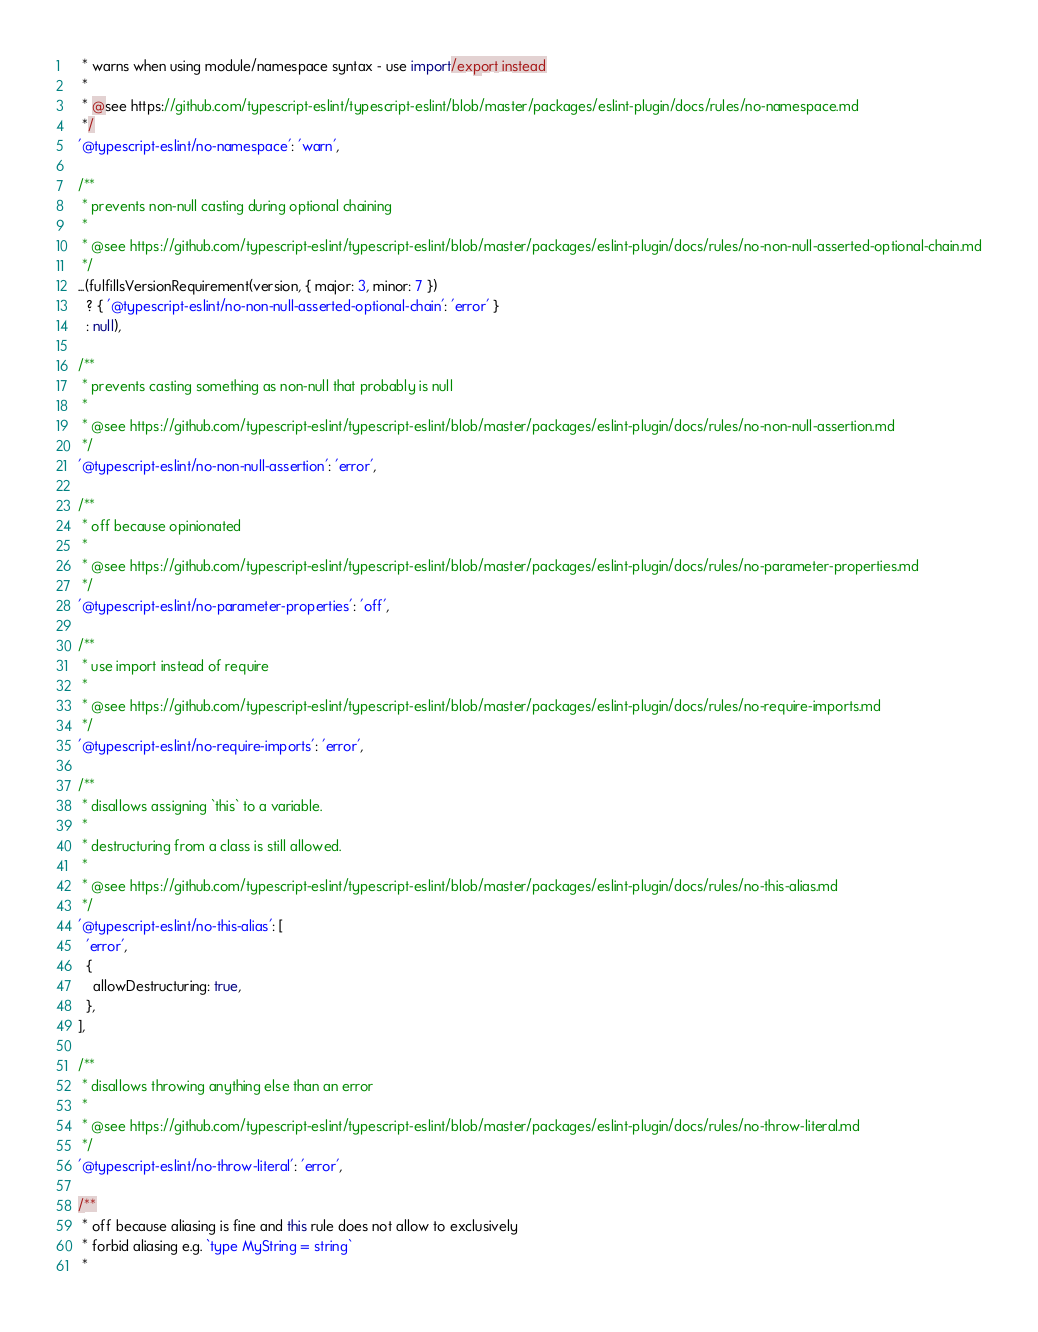<code> <loc_0><loc_0><loc_500><loc_500><_JavaScript_>   * warns when using module/namespace syntax - use import/export instead
   *
   * @see https://github.com/typescript-eslint/typescript-eslint/blob/master/packages/eslint-plugin/docs/rules/no-namespace.md
   */
  '@typescript-eslint/no-namespace': 'warn',

  /**
   * prevents non-null casting during optional chaining
   *
   * @see https://github.com/typescript-eslint/typescript-eslint/blob/master/packages/eslint-plugin/docs/rules/no-non-null-asserted-optional-chain.md
   */
  ...(fulfillsVersionRequirement(version, { major: 3, minor: 7 })
    ? { '@typescript-eslint/no-non-null-asserted-optional-chain': 'error' }
    : null),

  /**
   * prevents casting something as non-null that probably is null
   *
   * @see https://github.com/typescript-eslint/typescript-eslint/blob/master/packages/eslint-plugin/docs/rules/no-non-null-assertion.md
   */
  '@typescript-eslint/no-non-null-assertion': 'error',

  /**
   * off because opinionated
   *
   * @see https://github.com/typescript-eslint/typescript-eslint/blob/master/packages/eslint-plugin/docs/rules/no-parameter-properties.md
   */
  '@typescript-eslint/no-parameter-properties': 'off',

  /**
   * use import instead of require
   *
   * @see https://github.com/typescript-eslint/typescript-eslint/blob/master/packages/eslint-plugin/docs/rules/no-require-imports.md
   */
  '@typescript-eslint/no-require-imports': 'error',

  /**
   * disallows assigning `this` to a variable.
   *
   * destructuring from a class is still allowed.
   *
   * @see https://github.com/typescript-eslint/typescript-eslint/blob/master/packages/eslint-plugin/docs/rules/no-this-alias.md
   */
  '@typescript-eslint/no-this-alias': [
    'error',
    {
      allowDestructuring: true,
    },
  ],

  /**
   * disallows throwing anything else than an error
   *
   * @see https://github.com/typescript-eslint/typescript-eslint/blob/master/packages/eslint-plugin/docs/rules/no-throw-literal.md
   */
  '@typescript-eslint/no-throw-literal': 'error',

  /**
   * off because aliasing is fine and this rule does not allow to exclusively
   * forbid aliasing e.g. `type MyString = string`
   *</code> 